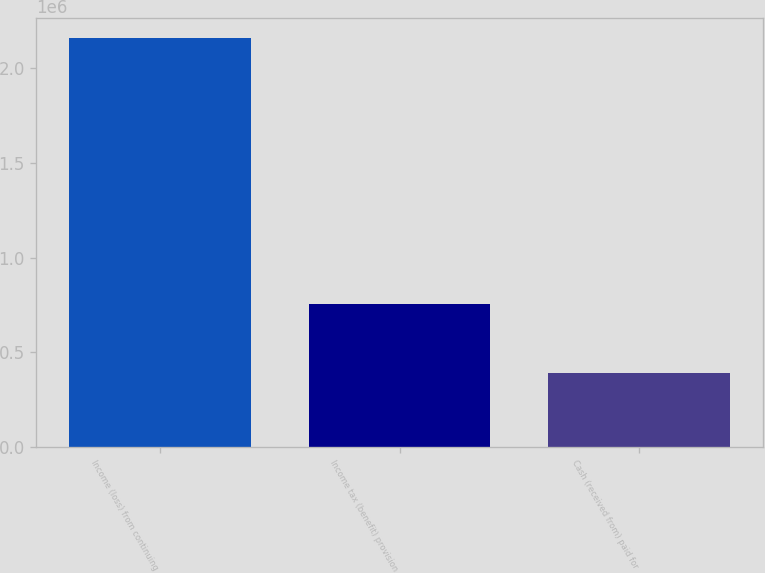<chart> <loc_0><loc_0><loc_500><loc_500><bar_chart><fcel>Income (loss) from continuing<fcel>Income tax (benefit) provision<fcel>Cash (received from) paid for<nl><fcel>2.15843e+06<fcel>757883<fcel>391042<nl></chart> 